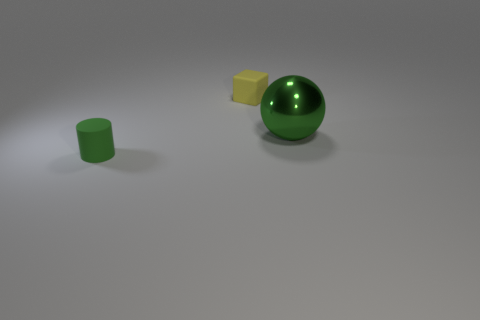Add 3 tiny yellow things. How many objects exist? 6 Subtract 1 spheres. How many spheres are left? 0 Subtract all cylinders. How many objects are left? 2 Add 1 rubber things. How many rubber things exist? 3 Subtract 0 purple balls. How many objects are left? 3 Subtract all purple cubes. Subtract all gray cylinders. How many cubes are left? 1 Subtract all tiny green rubber cylinders. Subtract all yellow cubes. How many objects are left? 1 Add 2 yellow cubes. How many yellow cubes are left? 3 